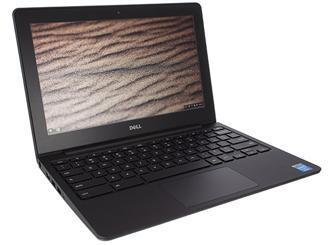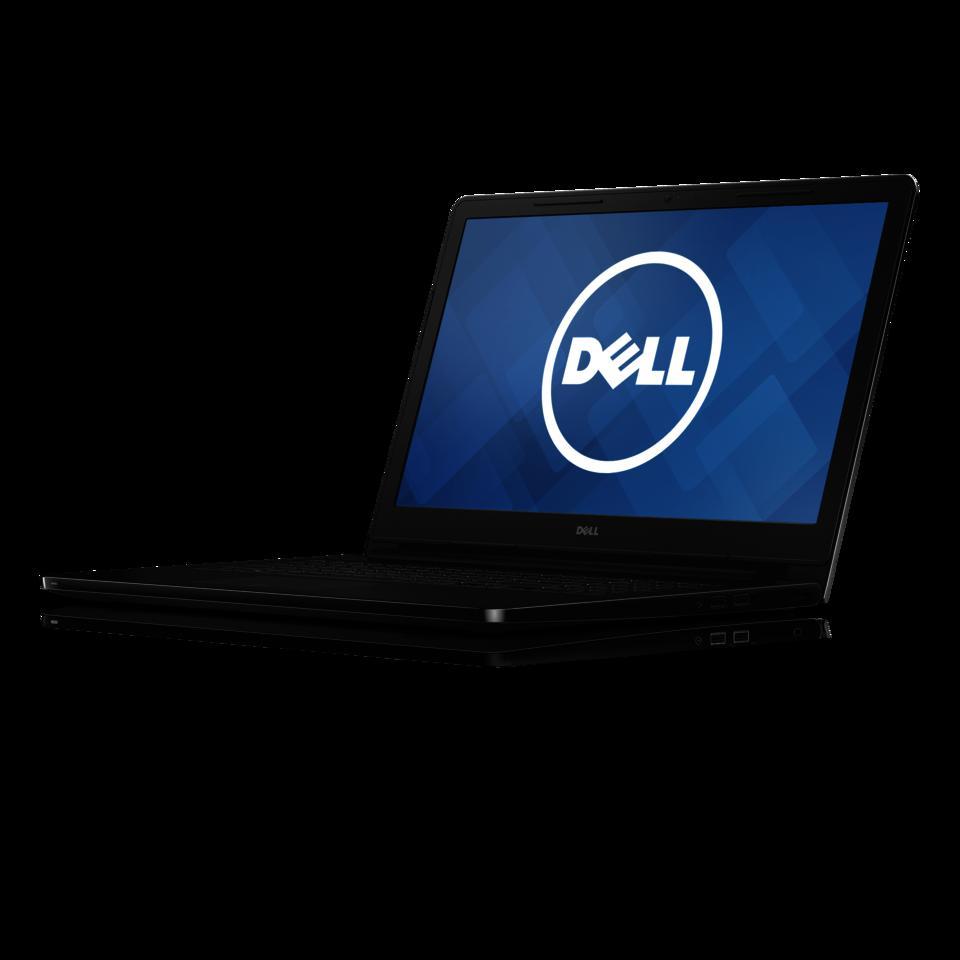The first image is the image on the left, the second image is the image on the right. Analyze the images presented: Is the assertion "One of the images shows an open laptop viewed head-on, with a screen displaying a blue background." valid? Answer yes or no. No. The first image is the image on the left, the second image is the image on the right. Evaluate the accuracy of this statement regarding the images: "One of the laptops has wallpaper that looks like light shining through a window.". Is it true? Answer yes or no. No. 